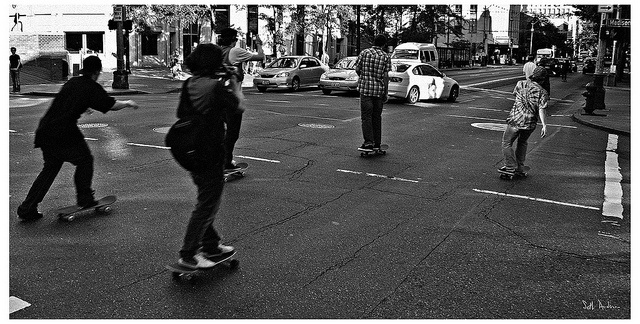Describe the objects in this image and their specific colors. I can see people in white, black, gray, darkgray, and lightgray tones, people in white, black, gray, darkgray, and lightgray tones, people in white, black, gray, darkgray, and lightgray tones, people in white, black, gray, darkgray, and lightgray tones, and car in white, black, gray, and darkgray tones in this image. 